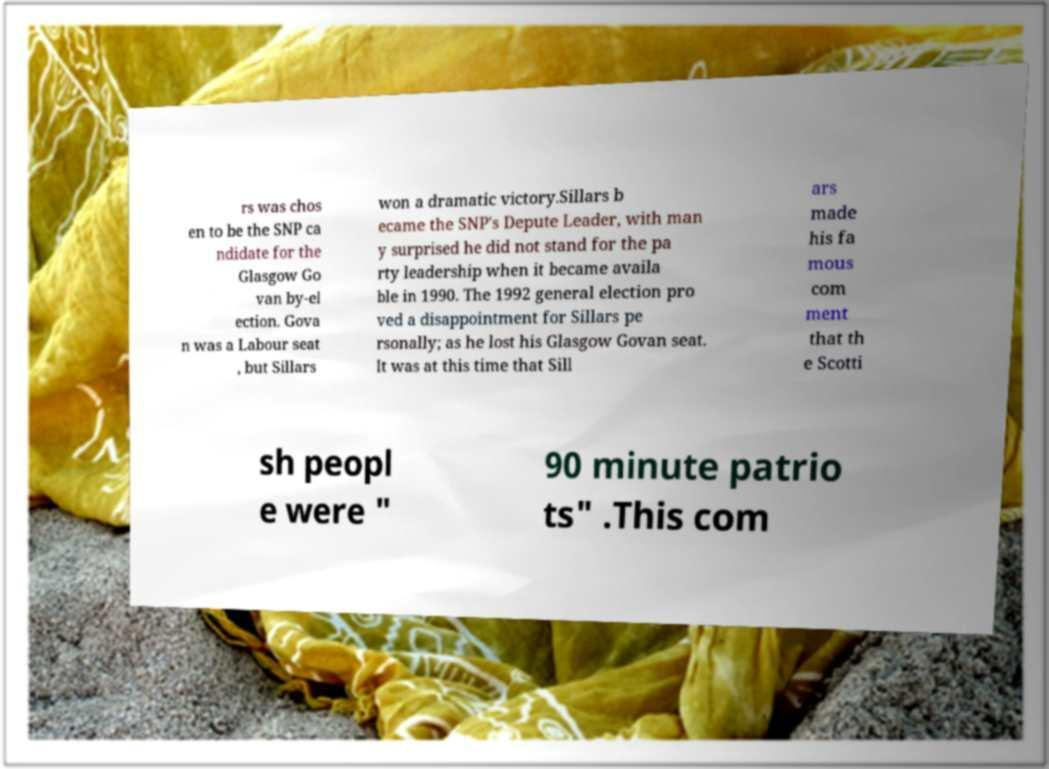Can you read and provide the text displayed in the image?This photo seems to have some interesting text. Can you extract and type it out for me? rs was chos en to be the SNP ca ndidate for the Glasgow Go van by-el ection. Gova n was a Labour seat , but Sillars won a dramatic victory.Sillars b ecame the SNP's Depute Leader, with man y surprised he did not stand for the pa rty leadership when it became availa ble in 1990. The 1992 general election pro ved a disappointment for Sillars pe rsonally; as he lost his Glasgow Govan seat. It was at this time that Sill ars made his fa mous com ment that th e Scotti sh peopl e were " 90 minute patrio ts" .This com 